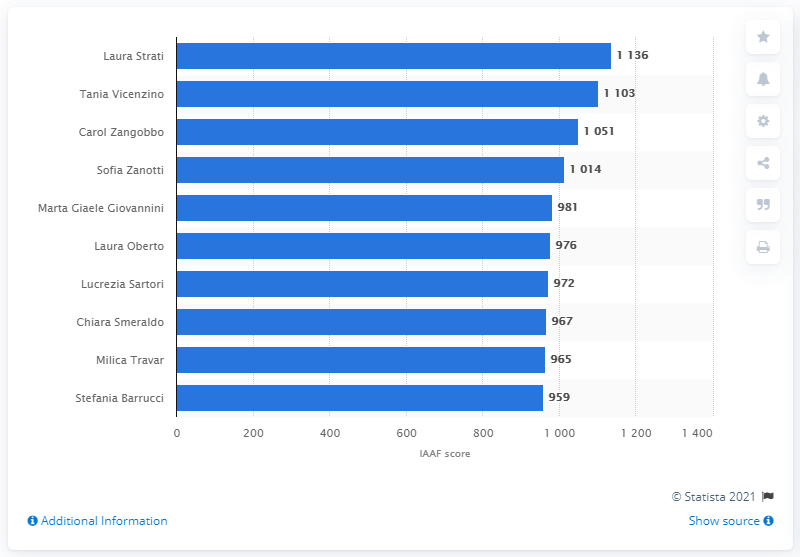Outline some significant characteristics in this image. Tania Vicenzino ranked second in the IAAF ranking as of December 2020. Laura Strati, an Italian female athlete, scored the highest number of points in the sport discipline of the long jump. 